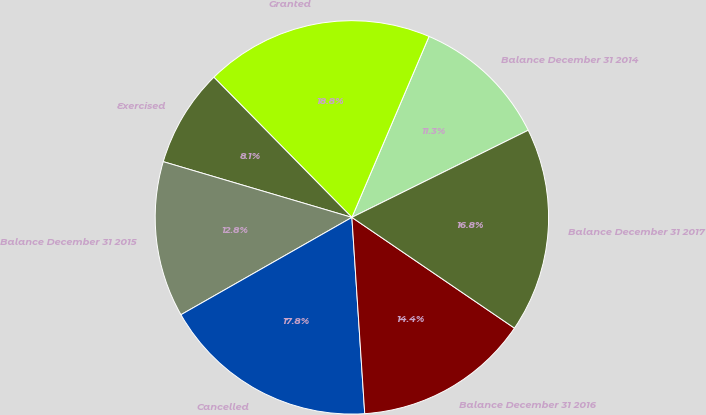Convert chart. <chart><loc_0><loc_0><loc_500><loc_500><pie_chart><fcel>Balance December 31 2014<fcel>Granted<fcel>Exercised<fcel>Balance December 31 2015<fcel>Cancelled<fcel>Balance December 31 2016<fcel>Balance December 31 2017<nl><fcel>11.28%<fcel>18.79%<fcel>8.05%<fcel>12.81%<fcel>17.8%<fcel>14.44%<fcel>16.82%<nl></chart> 